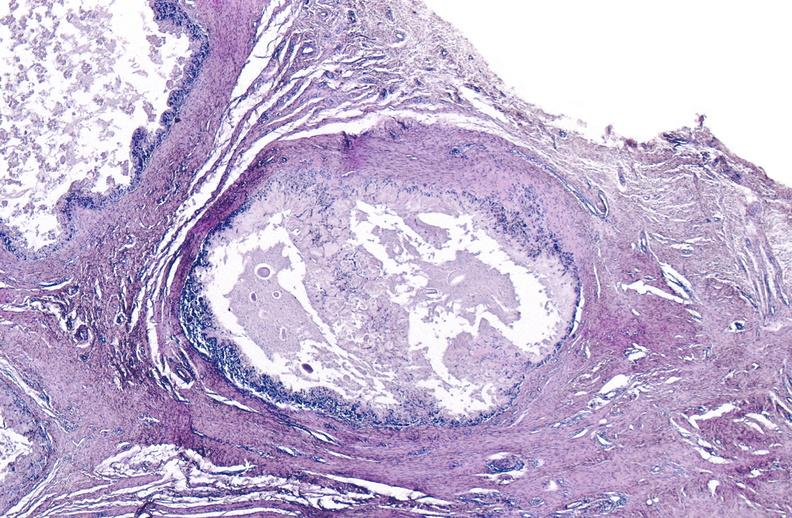s joints present?
Answer the question using a single word or phrase. Yes 